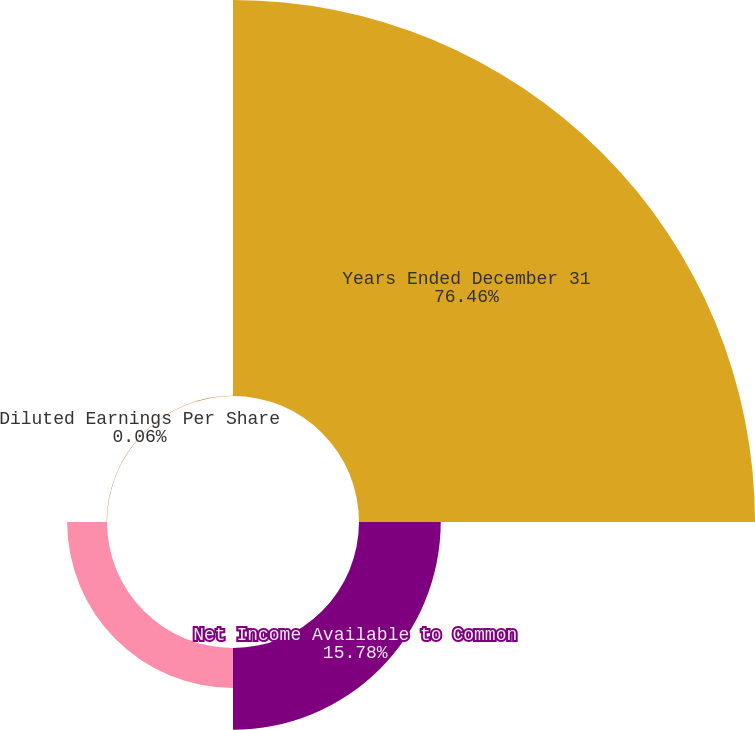Convert chart. <chart><loc_0><loc_0><loc_500><loc_500><pie_chart><fcel>Years Ended December 31<fcel>Net Income Available to Common<fcel>Basic Earnings Per Share<fcel>Diluted Earnings Per Share<nl><fcel>76.46%<fcel>15.78%<fcel>7.7%<fcel>0.06%<nl></chart> 